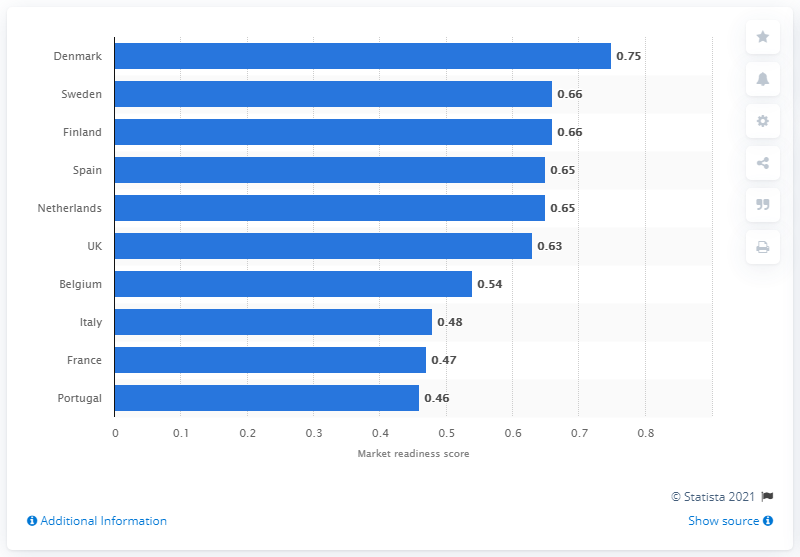Highlight a few significant elements in this photo. In 2015, the mHealth market readiness score for Denmark was 0.75. Denmark was the leading country in terms of market openness and preparation for mHealth business. 